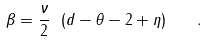<formula> <loc_0><loc_0><loc_500><loc_500>\beta = \frac { \nu } { 2 } \ ( d - \theta - 2 + \eta ) \quad .</formula> 